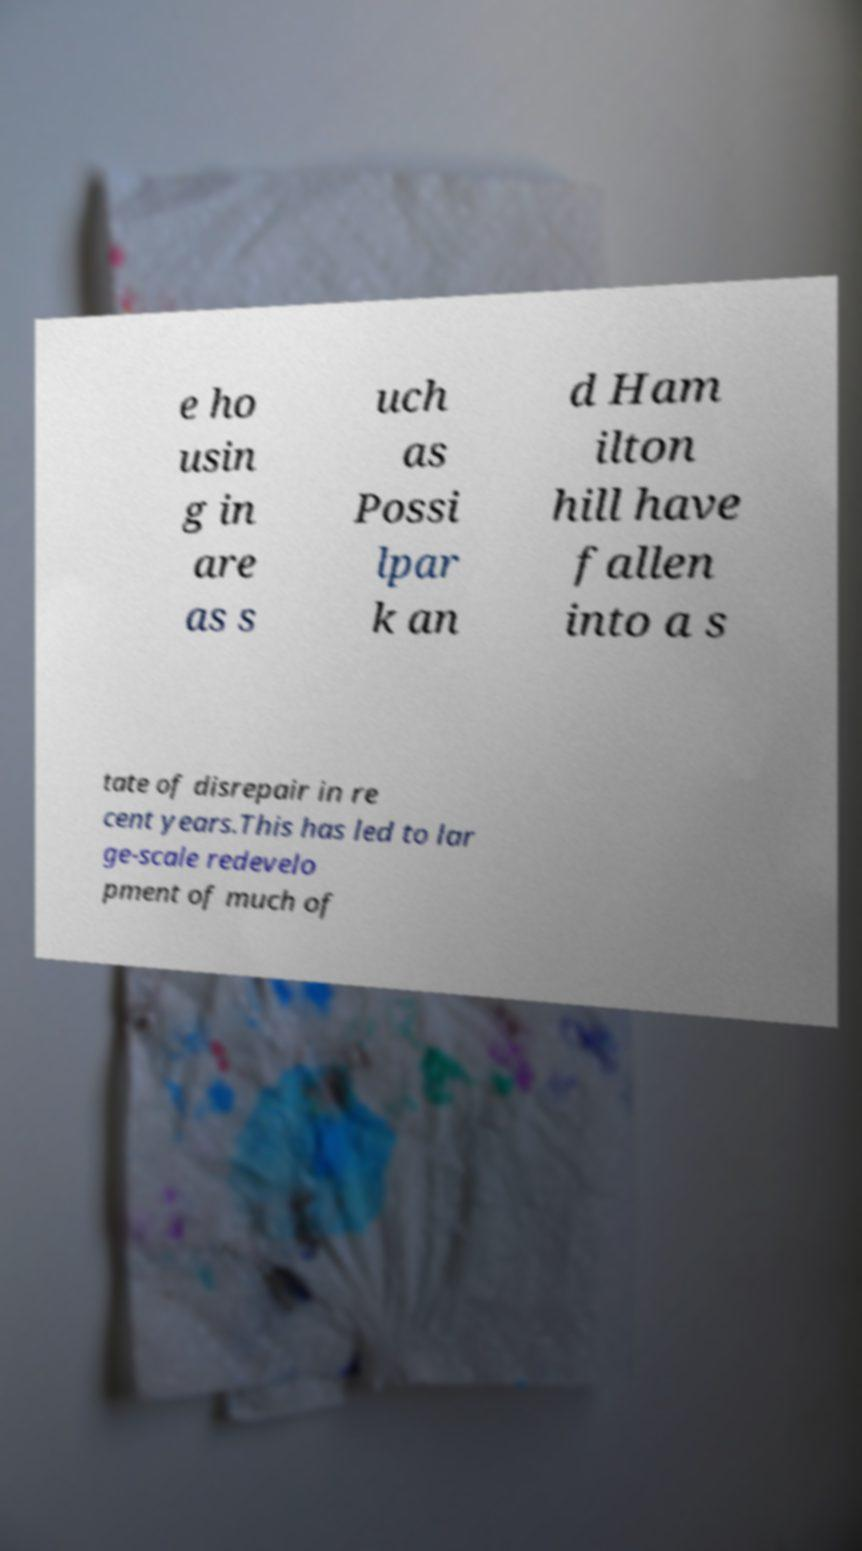Please read and relay the text visible in this image. What does it say? e ho usin g in are as s uch as Possi lpar k an d Ham ilton hill have fallen into a s tate of disrepair in re cent years.This has led to lar ge-scale redevelo pment of much of 